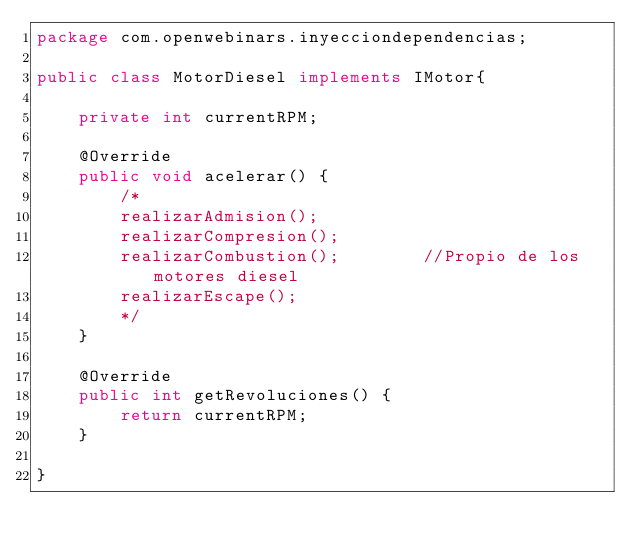<code> <loc_0><loc_0><loc_500><loc_500><_Java_>package com.openwebinars.inyecciondependencias;

public class MotorDiesel implements IMotor{

	private int currentRPM;
	
	@Override
	public void acelerar() {
		/*
		realizarAdmision();
        realizarCompresion();
        realizarCombustion();        //Propio de los motores diesel
        realizarEscape();		 
        */
	}

	@Override
	public int getRevoluciones() {
		return currentRPM;
	}

}
</code> 